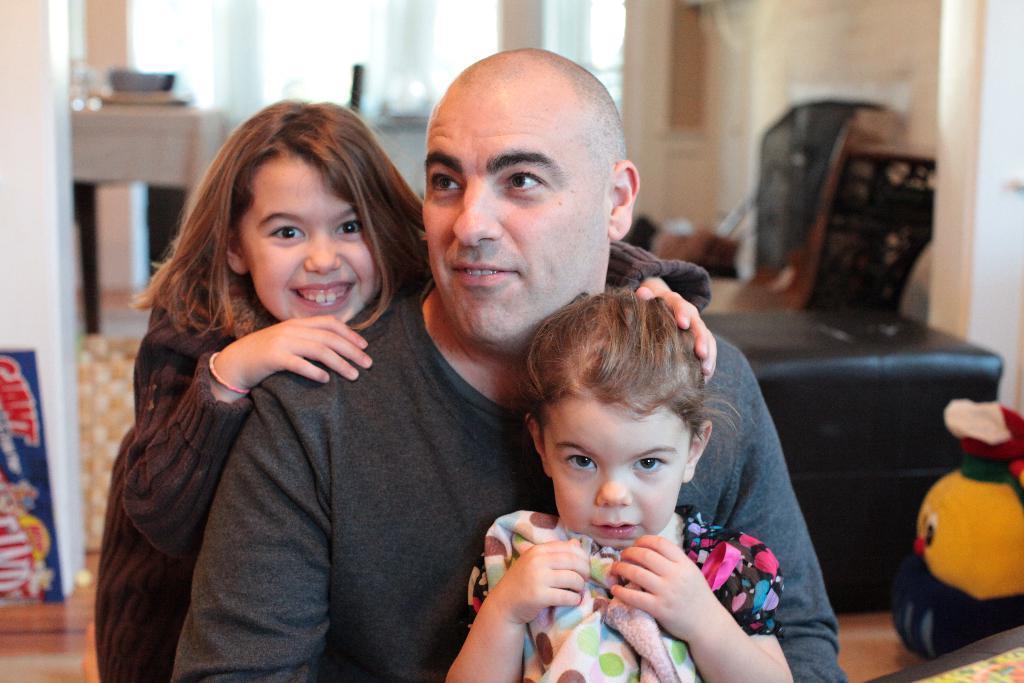Please provide a concise description of this image. In this image there is a man towards the bottom of the image, there are two girls towards the bottom of the image, there is a toy towards the right of the image, there is an object towards the bottom of the image, there is a wall towards the right of the image, there is a floor towards the bottom of the image, there are objects on the floor, there are windows towards the top of the image, there is a table, there are objects on the table, there is a wall towards the left of the image, there is an object towards the left of the image, there is text on the object. 